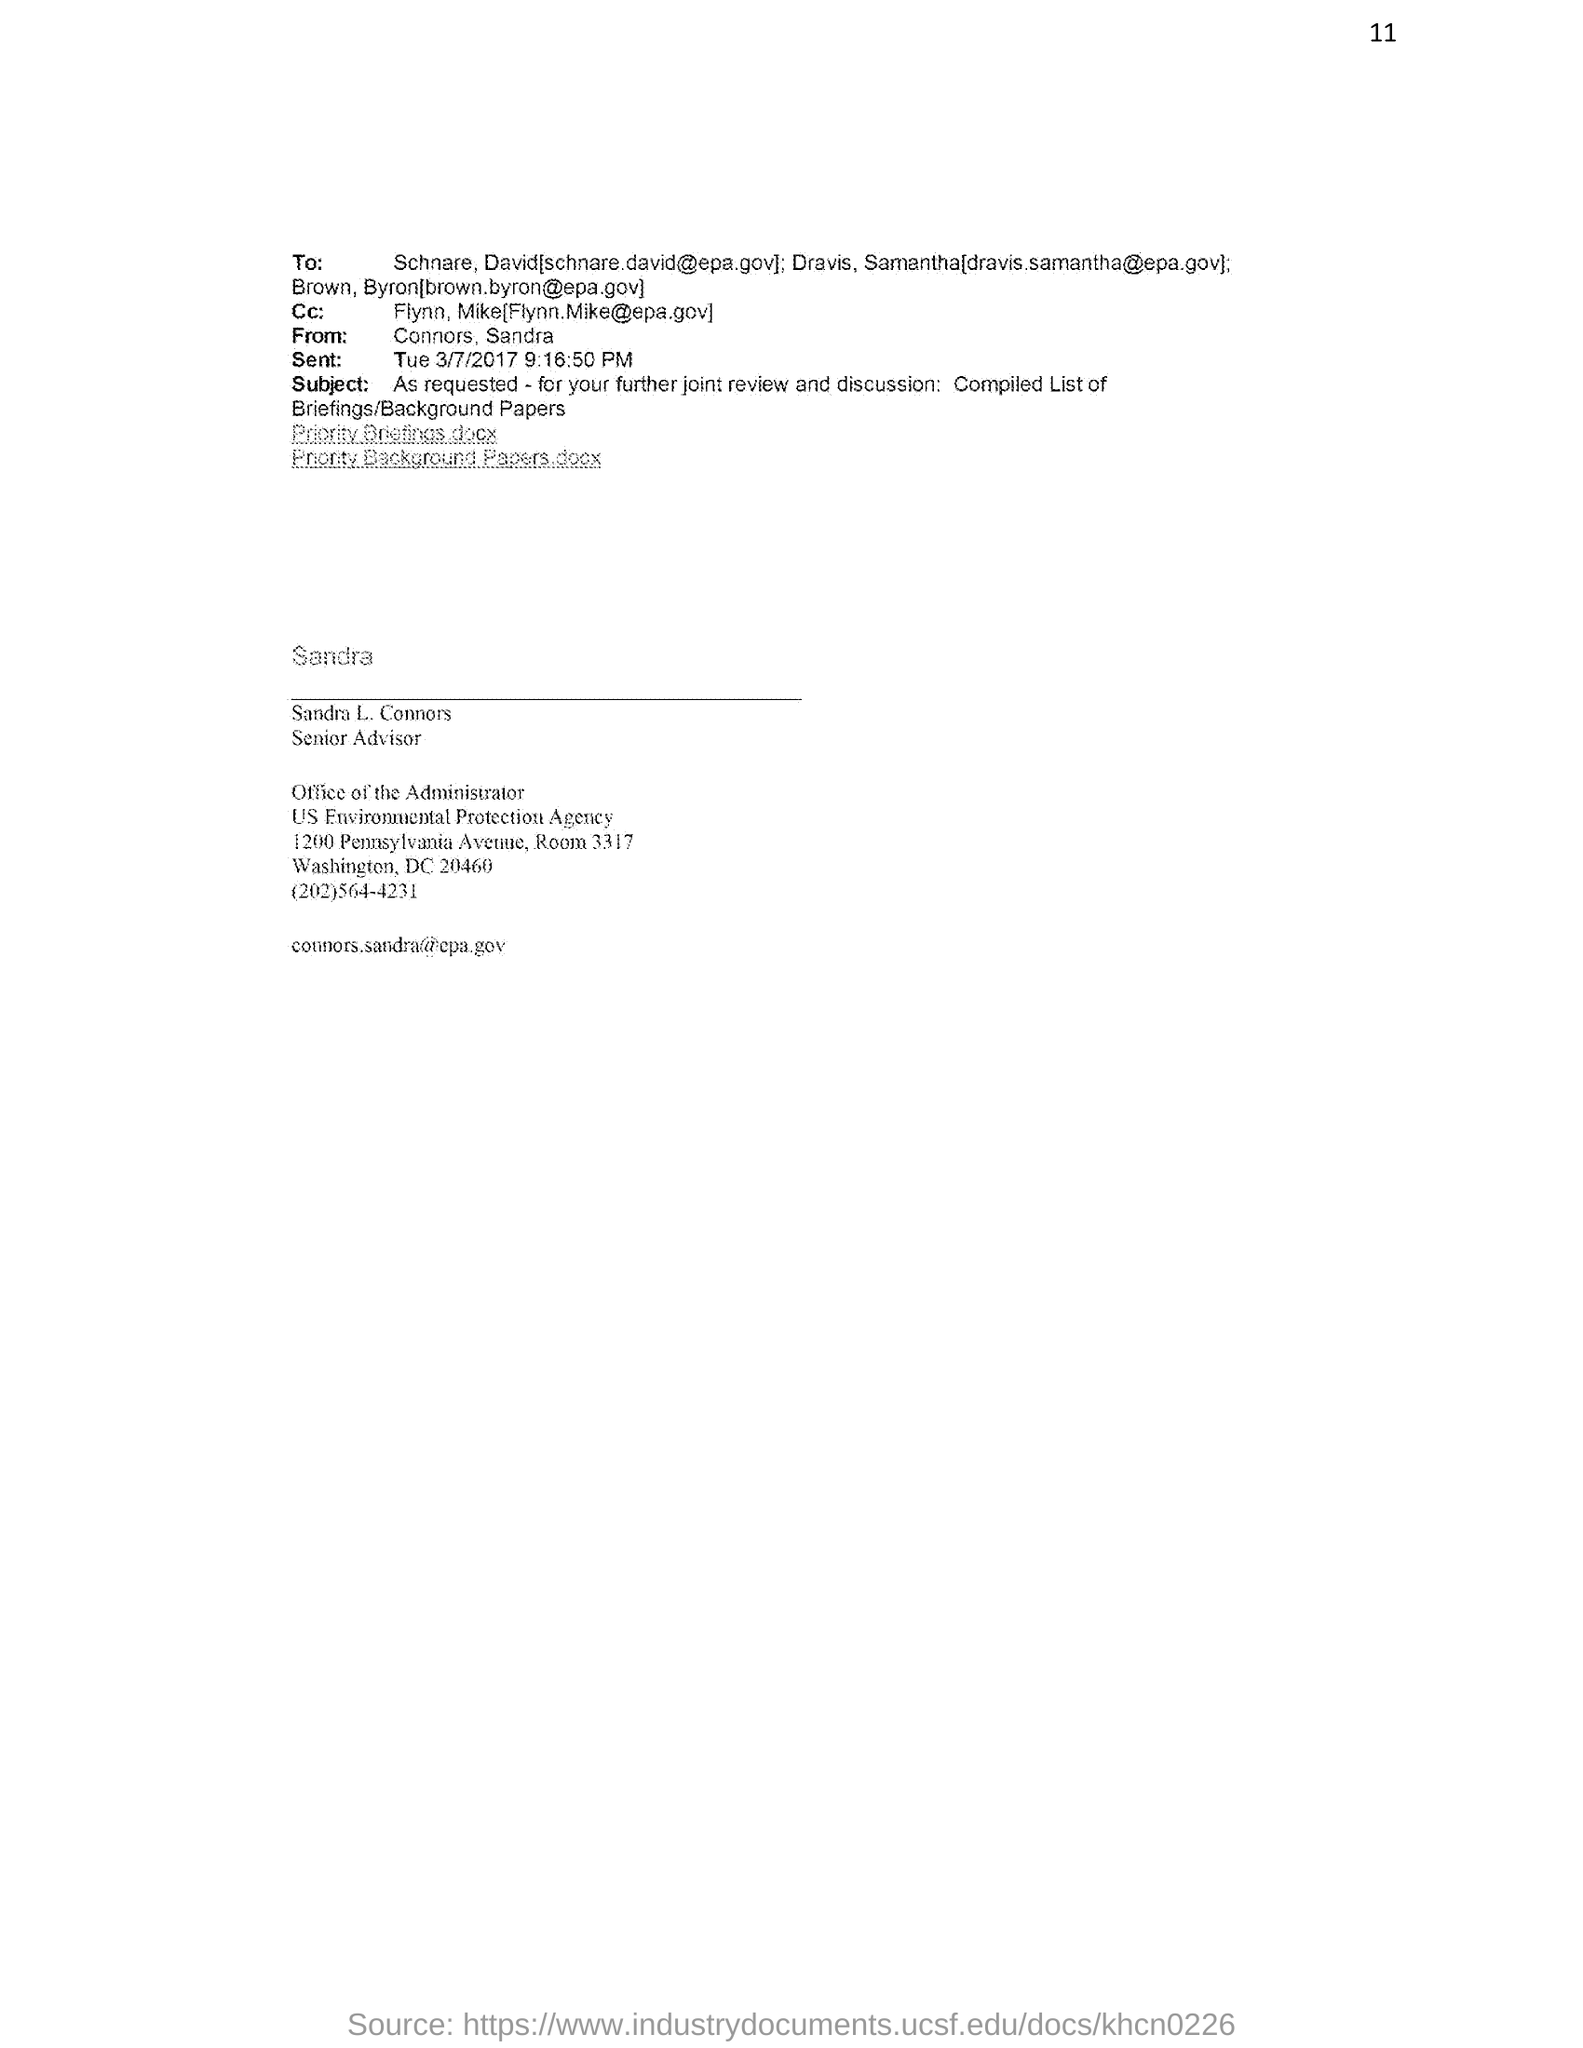Point out several critical features in this image. Sandra L. Connors holds the designation of Senior Advisor. Sandra L. Connors can be contacted through her email id [connors.sandra@epa.gov](mailto:connors.sandra@epa.gov). The contact number of Sandra L. Connors is (202)564-4231. The subject of the email from Sandra L. Connors is "Compiled List of Briefings/Background Papers," which has been requested for further joint review and discussion. The sent date and time of the email from Sandra L. Connors is March 7th, 2017 at 9:16:50 PM. 